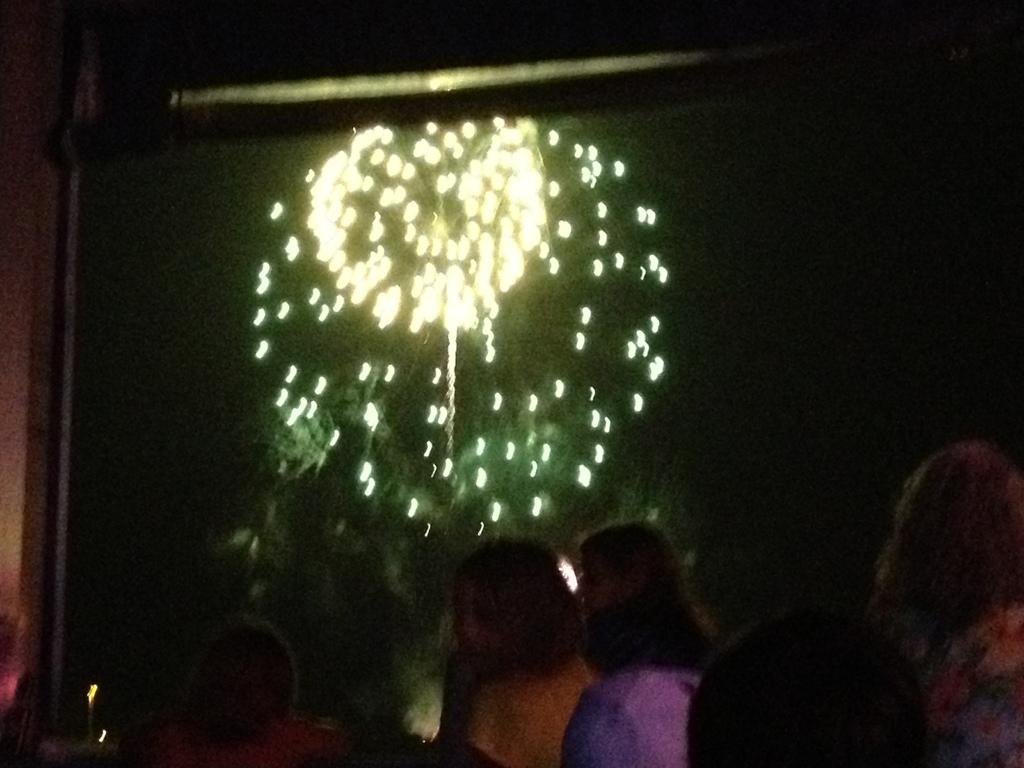What is the main subject of the image? The main subject of the image is a group of people. What can be seen in addition to the people in the image? There are lights visible in the image. What is the color of the background in the image? The background of the image is black. How many pumpkins are being carried by the chickens in the image? There are no pumpkins or chickens present in the image. What is the group of people hoping for in the image? The image does not provide any information about the group's hopes or intentions. 